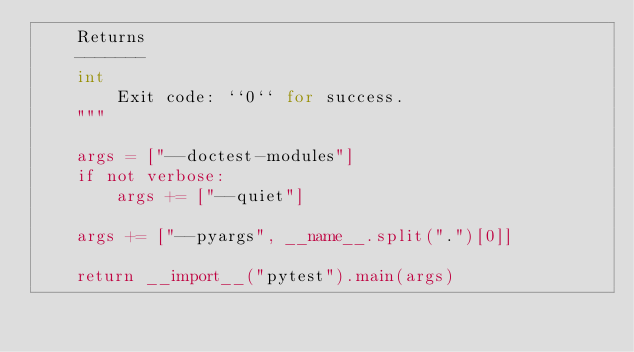Convert code to text. <code><loc_0><loc_0><loc_500><loc_500><_Python_>    Returns
    -------
    int
        Exit code: ``0`` for success.
    """

    args = ["--doctest-modules"]
    if not verbose:
        args += ["--quiet"]

    args += ["--pyargs", __name__.split(".")[0]]

    return __import__("pytest").main(args)
</code> 